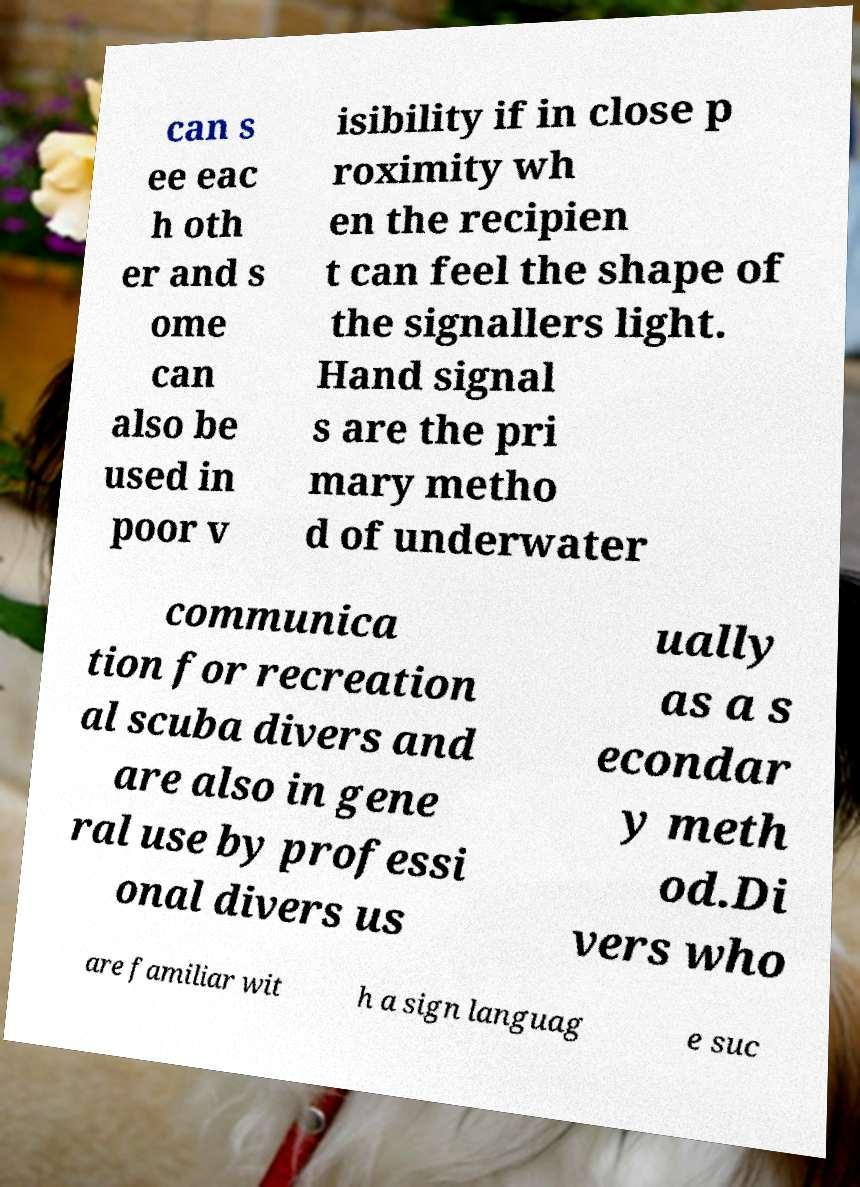Could you assist in decoding the text presented in this image and type it out clearly? can s ee eac h oth er and s ome can also be used in poor v isibility if in close p roximity wh en the recipien t can feel the shape of the signallers light. Hand signal s are the pri mary metho d of underwater communica tion for recreation al scuba divers and are also in gene ral use by professi onal divers us ually as a s econdar y meth od.Di vers who are familiar wit h a sign languag e suc 